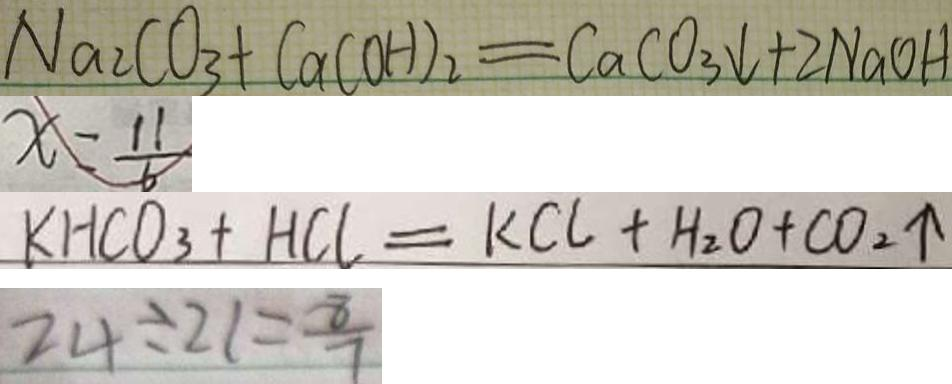<formula> <loc_0><loc_0><loc_500><loc_500>N a _ { 2 } C O _ { 3 } + C a ( O H ) _ { 2 } = C a C O _ { 3 } \downarrow + 2 N a O H 
 x = \frac { 1 1 } { 6 } 
 K H C O _ { 3 } + H C l = K C l + H _ { 2 } O + C O _ { 2 } \uparrow 
 2 4 \div 2 1 = \frac { 8 } { 7 }</formula> 